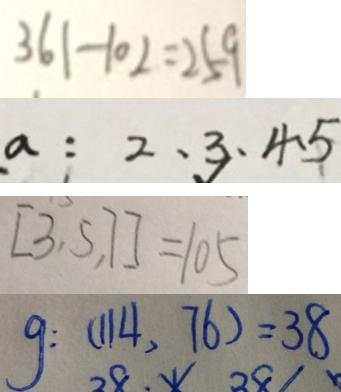<formula> <loc_0><loc_0><loc_500><loc_500>3 6 1 - 1 0 2 = 2 5 9 
 a : 2 、 3 、 4 、 5 
 [ 3 , 5 , 7 ] = 1 0 5 
 g : ( 1 1 4 . 7 6 ) = 3 8</formula> 